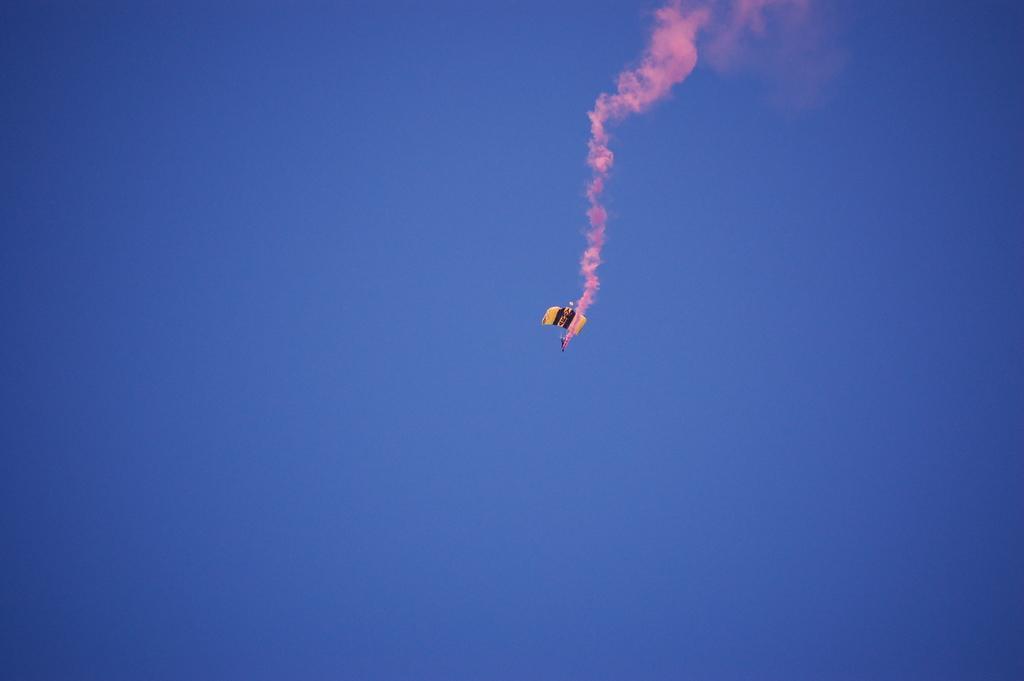Please provide a concise description of this image. In this image we can see a parachute, there is color in the sky. 